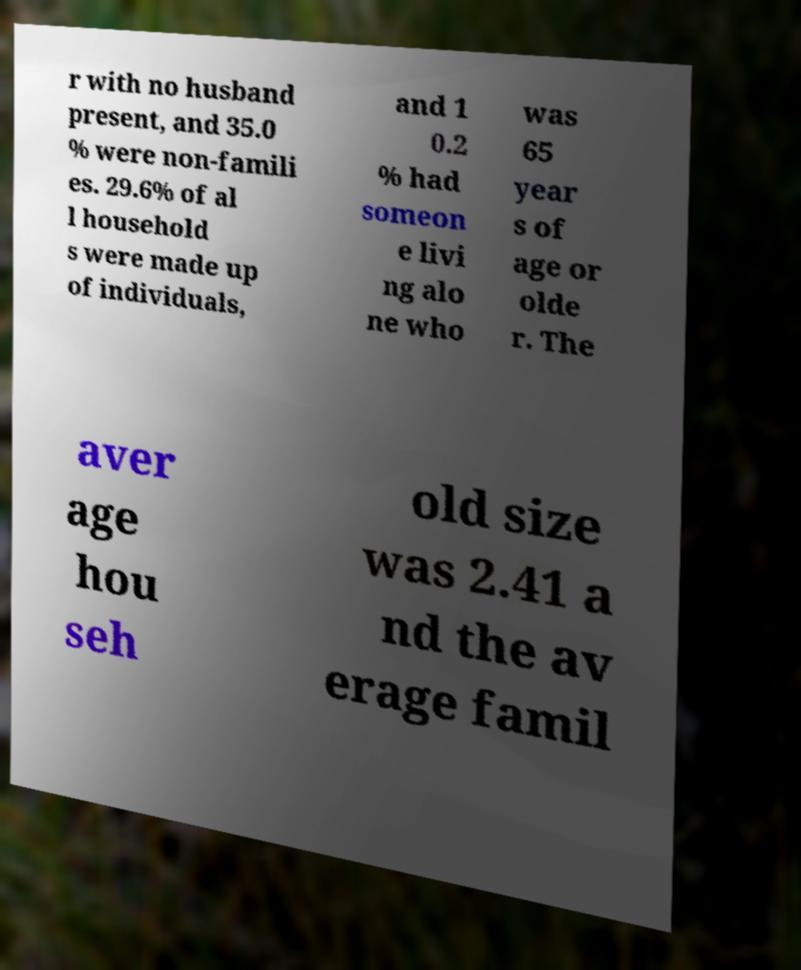For documentation purposes, I need the text within this image transcribed. Could you provide that? r with no husband present, and 35.0 % were non-famili es. 29.6% of al l household s were made up of individuals, and 1 0.2 % had someon e livi ng alo ne who was 65 year s of age or olde r. The aver age hou seh old size was 2.41 a nd the av erage famil 